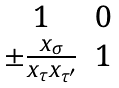<formula> <loc_0><loc_0><loc_500><loc_500>\begin{matrix} 1 & 0 \\ \pm \frac { x _ { \sigma } } { x _ { \tau } x _ { \tau ^ { \prime } } } & 1 \end{matrix}</formula> 